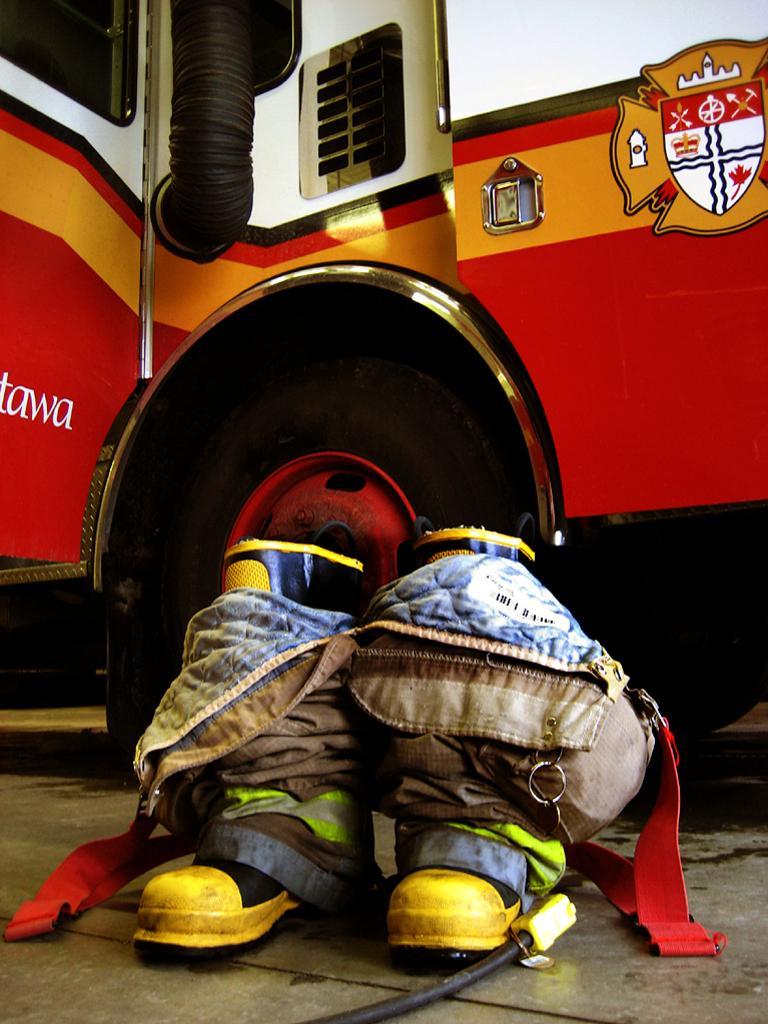In one or two sentences, can you explain what this image depicts? In the picture we can see a part of the truck with a wheel and near to it on the floor, we can see a pair of shoes which are yellow in color and some bag tied to it. 